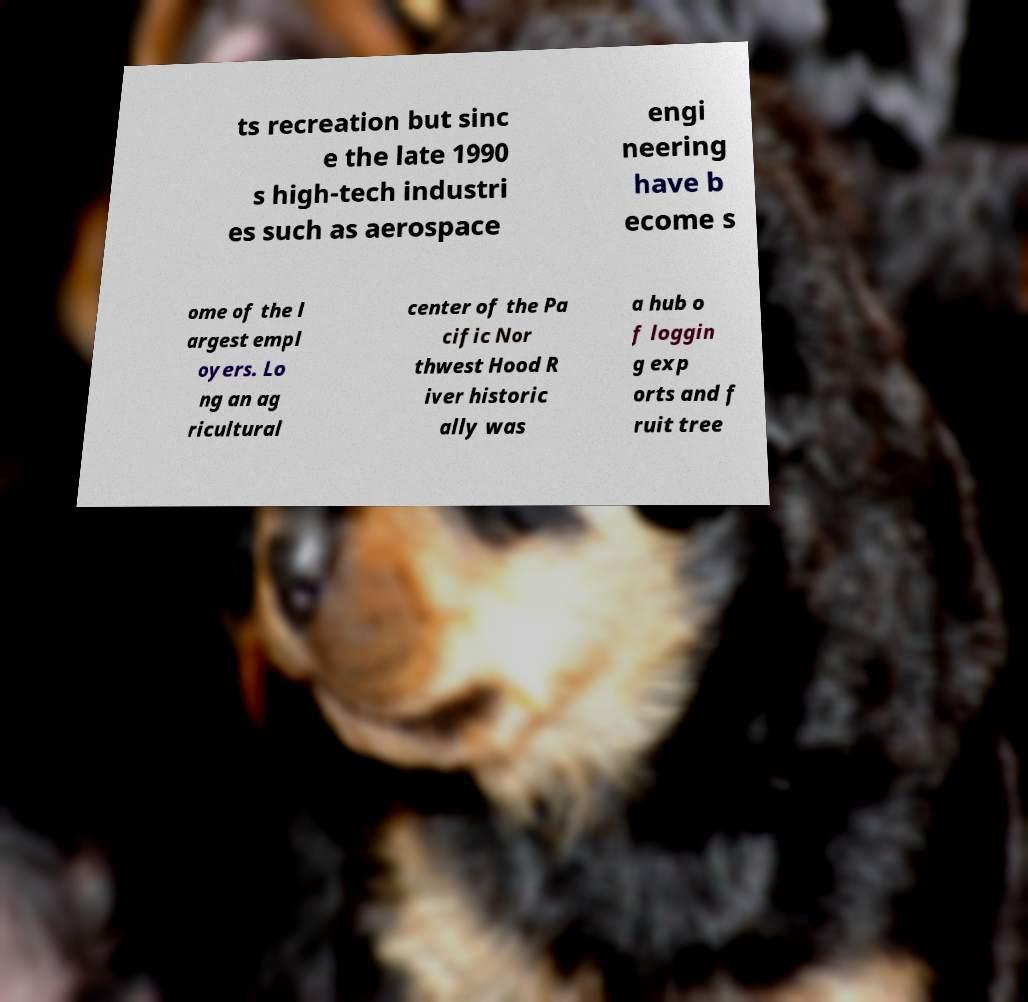I need the written content from this picture converted into text. Can you do that? ts recreation but sinc e the late 1990 s high-tech industri es such as aerospace engi neering have b ecome s ome of the l argest empl oyers. Lo ng an ag ricultural center of the Pa cific Nor thwest Hood R iver historic ally was a hub o f loggin g exp orts and f ruit tree 